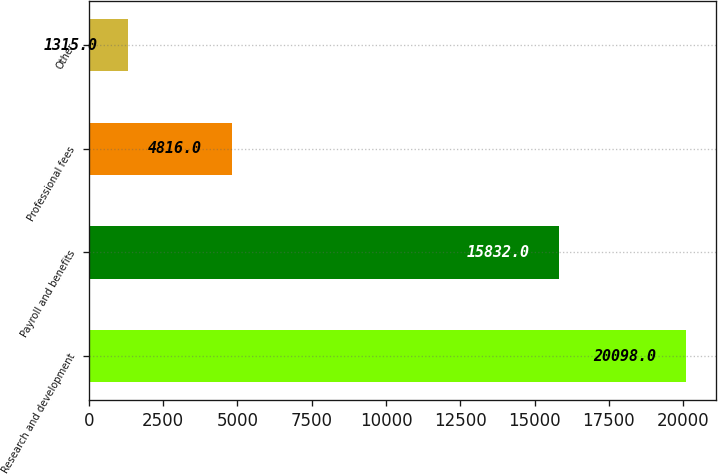Convert chart to OTSL. <chart><loc_0><loc_0><loc_500><loc_500><bar_chart><fcel>Research and development<fcel>Payroll and benefits<fcel>Professional fees<fcel>Other<nl><fcel>20098<fcel>15832<fcel>4816<fcel>1315<nl></chart> 